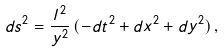Convert formula to latex. <formula><loc_0><loc_0><loc_500><loc_500>d s ^ { 2 } = \frac { l ^ { 2 } } { y ^ { 2 } } \, ( - d t ^ { 2 } + d x ^ { 2 } + d y ^ { 2 } ) \, ,</formula> 